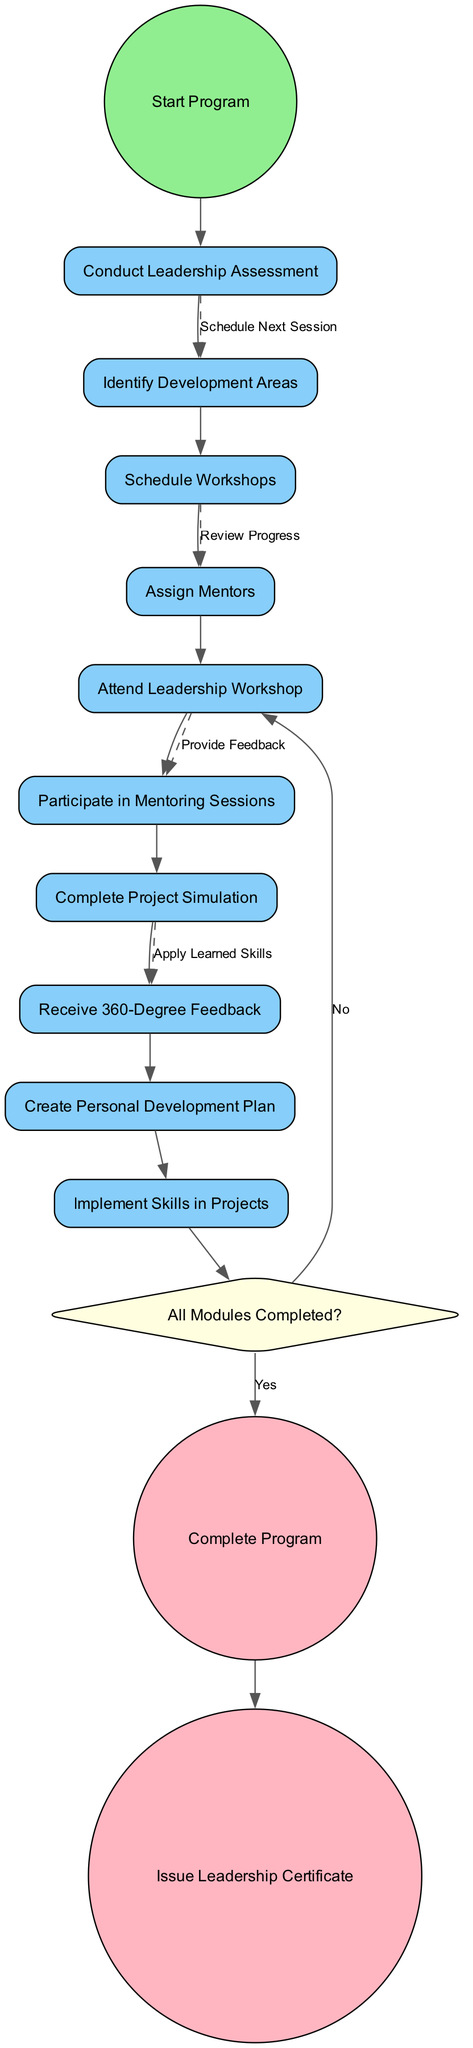What is the initial node of the diagram? The initial node is labeled "Start Program," which indicates where the leadership development program begins.
Answer: Start Program How many activities are listed in the diagram? There are ten activities present in the diagram, as indicated in the activities section.
Answer: 10 What is the condition of the decision node? The decision node's condition is "All Modules Completed?" which is needed to determine the next step in the process.
Answer: All Modules Completed? Which activity follows "Attend Leadership Workshop"? After "Attend Leadership Workshop," the next activity is "Participate in Mentoring Sessions," as this flow directly connects to it.
Answer: Participate in Mentoring Sessions What happens if "All Modules Completed?" is answered with "No"? If the answer to the decision "All Modules Completed?" is "No," the process continues with "Continue Program," indicating that further steps are taken before completion.
Answer: Continue Program Which node issues the Leadership Certificate? The node that issues the Leadership Certificate is the final node labeled "Issue Leadership Certificate." This indicates the conclusion of the program.
Answer: Issue Leadership Certificate How many edges are there between the activities? There are eleven edges connecting the activities, as each edge represents the transition from one activity to the next and includes additional dashed edges for specific connections.
Answer: 11 What is the last activity before conducting a final evaluation? The last activity before conducting a final evaluation is "Complete Project Simulation," which leads into the decision about completing the modules.
Answer: Complete Project Simulation What is the relationship between "Receive 360-Degree Feedback" and "Create Personal Development Plan"? The relationship is a sequential connection where "Receive 360-Degree Feedback" comes before "Create Personal Development Plan," indicating that feedback is gathered before the personal plan is made.
Answer: Sequential connection 